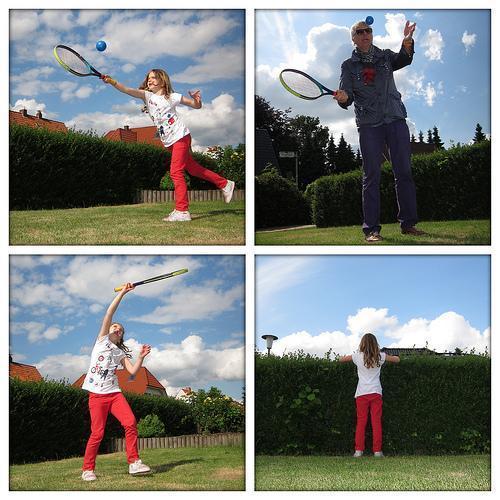How many people are shown in the images?
Give a very brief answer. 2. 